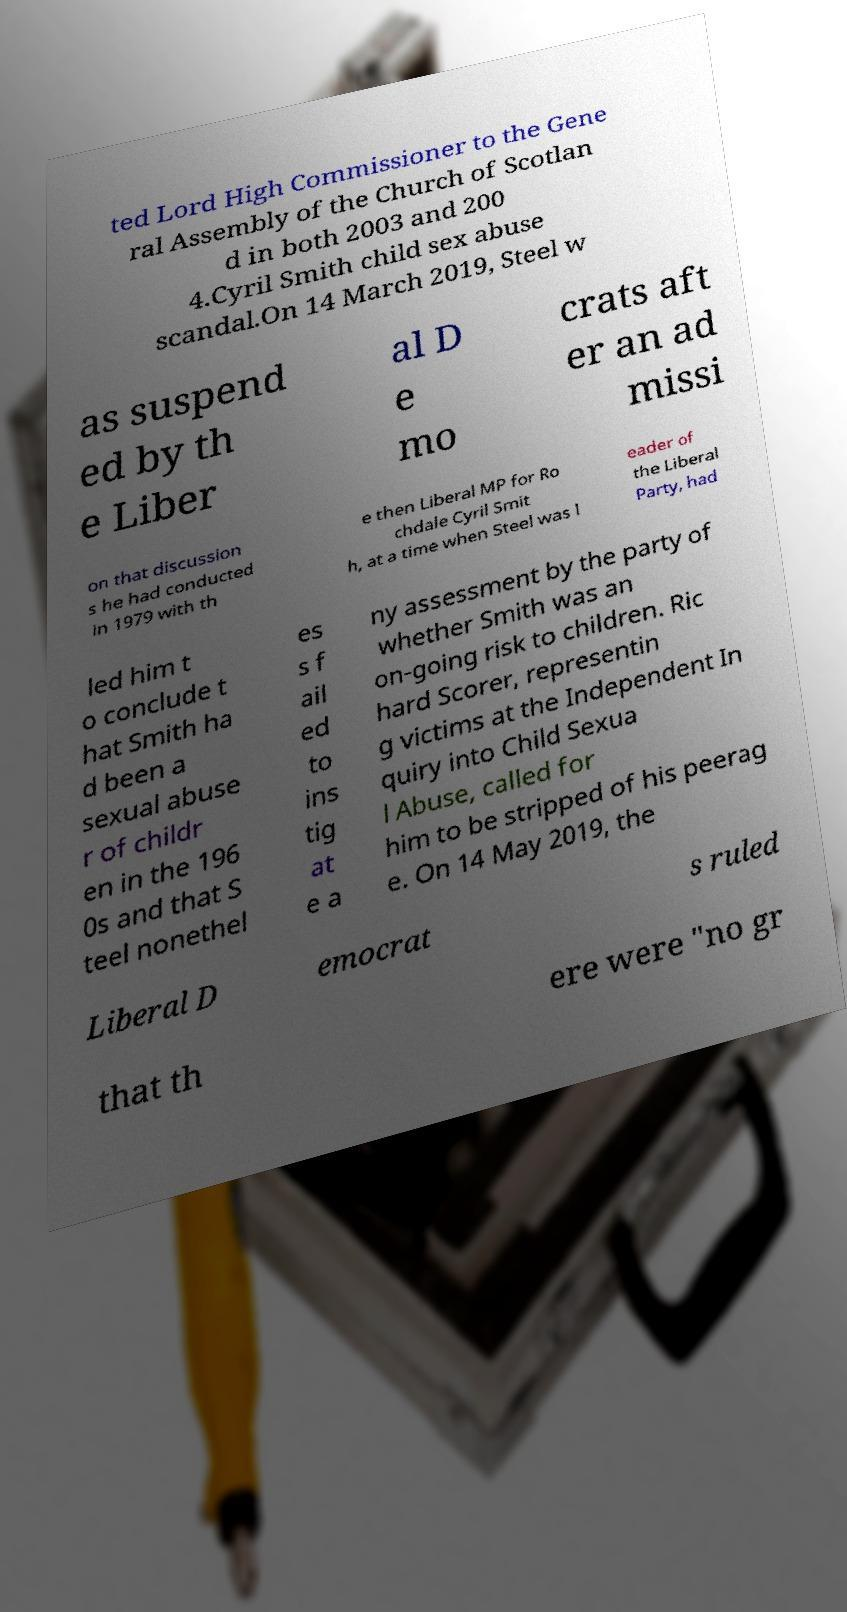Please read and relay the text visible in this image. What does it say? ted Lord High Commissioner to the Gene ral Assembly of the Church of Scotlan d in both 2003 and 200 4.Cyril Smith child sex abuse scandal.On 14 March 2019, Steel w as suspend ed by th e Liber al D e mo crats aft er an ad missi on that discussion s he had conducted in 1979 with th e then Liberal MP for Ro chdale Cyril Smit h, at a time when Steel was l eader of the Liberal Party, had led him t o conclude t hat Smith ha d been a sexual abuse r of childr en in the 196 0s and that S teel nonethel es s f ail ed to ins tig at e a ny assessment by the party of whether Smith was an on-going risk to children. Ric hard Scorer, representin g victims at the Independent In quiry into Child Sexua l Abuse, called for him to be stripped of his peerag e. On 14 May 2019, the Liberal D emocrat s ruled that th ere were "no gr 